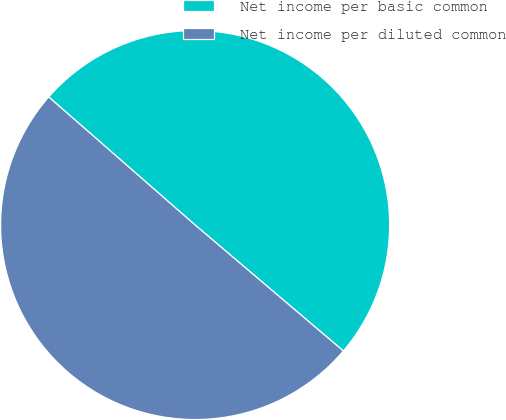Convert chart to OTSL. <chart><loc_0><loc_0><loc_500><loc_500><pie_chart><fcel>Net income per basic common<fcel>Net income per diluted common<nl><fcel>49.77%<fcel>50.23%<nl></chart> 